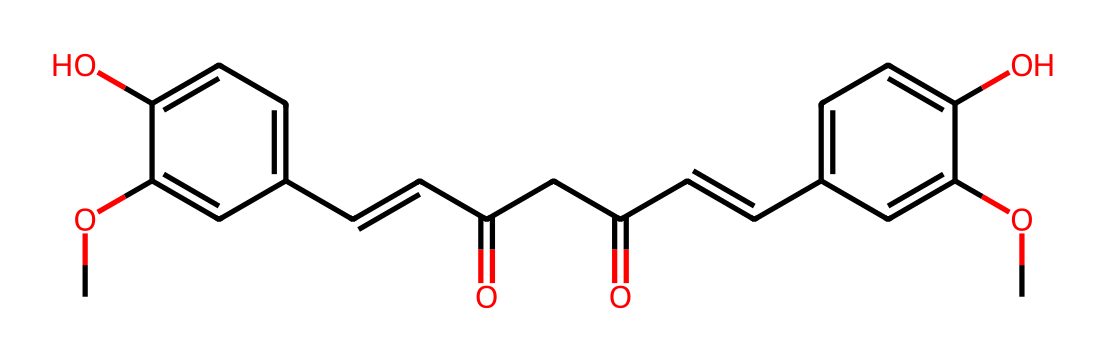How many rings are present in the structure? The chemical structure of curcumin contains two distinct aromatic rings. These are evident from the cyclic arrangement of carbon atoms within the two sets of alternating double bonds, indicating the presence of aromaticity in the structure.
Answer: two What is the functional group present that indicates the presence of a phenolic compound? The presence of the -OH (hydroxyl) groups attached to the aromatic rings indicates that this compound contains phenolic functional groups, which are characteristic of phenols.
Answer: -OH What is the molecular weight of curcumin? By summing the atomic weights of each element present in the SMILES representation, we find that the molecular weight of curcumin is approximately 368.38 g/mol, which is calculated based on the number of atoms of each element in the structure.
Answer: 368.38 g/mol What type of bonding is primarily present in curcumin? The primary type of bonding present in curcumin is covalent bonding, which is seen in the connections between the carbon, hydrogen, and oxygen atoms. Each atom shares electrons to form stable bonds in the molecular structure.
Answer: covalent What specific type of compound is curcumin classified as? Curcumin is classified as a polyphenolic compound due to the multiple phenolic structures it possesses, contributing to its antioxidant properties and medicinal potential.
Answer: polyphenol Which part of the chemical structure is responsible for its yellow color? The conjugated double bond system, specifically in the central chain connecting the two aromatic rings, endows curcumin with extended delocalization of electrons, resulting in its characteristic yellow color.
Answer: conjugated double bond system 